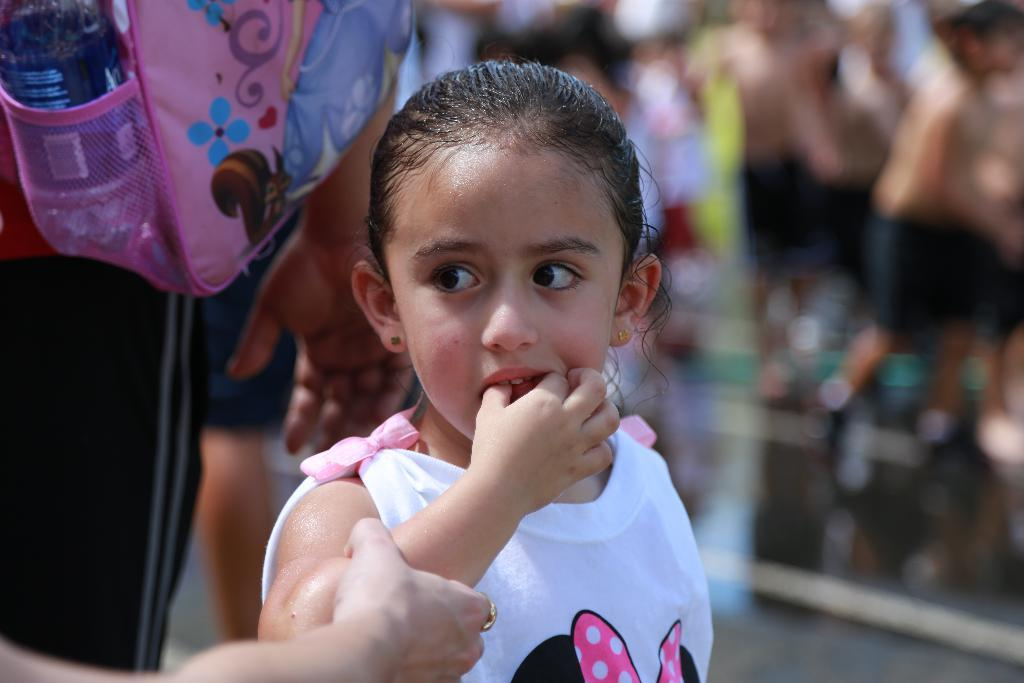What can be observed about the people in the image? There are people standing in the image. Can you describe the girl in the image? There is a girl in the image. What is the relationship between the girl and another person in the image? A human hand is holding the girl's hand. What is one person carrying in the image? There is a human holding a backpack in the image. What is another item visible in the image? A water bottle is visible in the image. What type of feather is the girl wearing on her sweater in the image? There is no feather or sweater visible on the girl in the image. What suggestion is being made by the person holding the girl's hand in the image? There is no indication of a suggestion being made in the image; it only shows a person holding the girl's hand. 